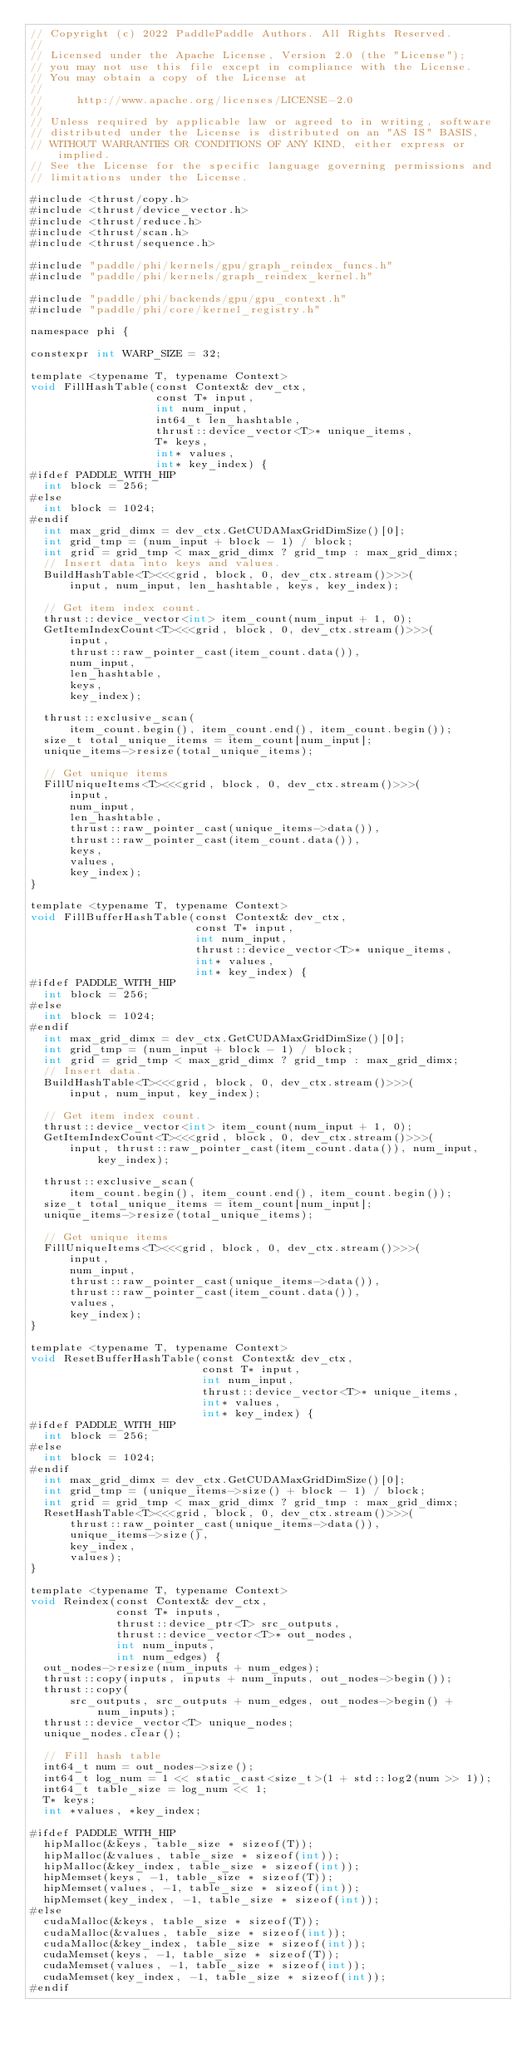Convert code to text. <code><loc_0><loc_0><loc_500><loc_500><_Cuda_>// Copyright (c) 2022 PaddlePaddle Authors. All Rights Reserved.
//
// Licensed under the Apache License, Version 2.0 (the "License");
// you may not use this file except in compliance with the License.
// You may obtain a copy of the License at
//
//     http://www.apache.org/licenses/LICENSE-2.0
//
// Unless required by applicable law or agreed to in writing, software
// distributed under the License is distributed on an "AS IS" BASIS,
// WITHOUT WARRANTIES OR CONDITIONS OF ANY KIND, either express or implied.
// See the License for the specific language governing permissions and
// limitations under the License.

#include <thrust/copy.h>
#include <thrust/device_vector.h>
#include <thrust/reduce.h>
#include <thrust/scan.h>
#include <thrust/sequence.h>

#include "paddle/phi/kernels/gpu/graph_reindex_funcs.h"
#include "paddle/phi/kernels/graph_reindex_kernel.h"

#include "paddle/phi/backends/gpu/gpu_context.h"
#include "paddle/phi/core/kernel_registry.h"

namespace phi {

constexpr int WARP_SIZE = 32;

template <typename T, typename Context>
void FillHashTable(const Context& dev_ctx,
                   const T* input,
                   int num_input,
                   int64_t len_hashtable,
                   thrust::device_vector<T>* unique_items,
                   T* keys,
                   int* values,
                   int* key_index) {
#ifdef PADDLE_WITH_HIP
  int block = 256;
#else
  int block = 1024;
#endif
  int max_grid_dimx = dev_ctx.GetCUDAMaxGridDimSize()[0];
  int grid_tmp = (num_input + block - 1) / block;
  int grid = grid_tmp < max_grid_dimx ? grid_tmp : max_grid_dimx;
  // Insert data into keys and values.
  BuildHashTable<T><<<grid, block, 0, dev_ctx.stream()>>>(
      input, num_input, len_hashtable, keys, key_index);

  // Get item index count.
  thrust::device_vector<int> item_count(num_input + 1, 0);
  GetItemIndexCount<T><<<grid, block, 0, dev_ctx.stream()>>>(
      input,
      thrust::raw_pointer_cast(item_count.data()),
      num_input,
      len_hashtable,
      keys,
      key_index);

  thrust::exclusive_scan(
      item_count.begin(), item_count.end(), item_count.begin());
  size_t total_unique_items = item_count[num_input];
  unique_items->resize(total_unique_items);

  // Get unique items
  FillUniqueItems<T><<<grid, block, 0, dev_ctx.stream()>>>(
      input,
      num_input,
      len_hashtable,
      thrust::raw_pointer_cast(unique_items->data()),
      thrust::raw_pointer_cast(item_count.data()),
      keys,
      values,
      key_index);
}

template <typename T, typename Context>
void FillBufferHashTable(const Context& dev_ctx,
                         const T* input,
                         int num_input,
                         thrust::device_vector<T>* unique_items,
                         int* values,
                         int* key_index) {
#ifdef PADDLE_WITH_HIP
  int block = 256;
#else
  int block = 1024;
#endif
  int max_grid_dimx = dev_ctx.GetCUDAMaxGridDimSize()[0];
  int grid_tmp = (num_input + block - 1) / block;
  int grid = grid_tmp < max_grid_dimx ? grid_tmp : max_grid_dimx;
  // Insert data.
  BuildHashTable<T><<<grid, block, 0, dev_ctx.stream()>>>(
      input, num_input, key_index);

  // Get item index count.
  thrust::device_vector<int> item_count(num_input + 1, 0);
  GetItemIndexCount<T><<<grid, block, 0, dev_ctx.stream()>>>(
      input, thrust::raw_pointer_cast(item_count.data()), num_input, key_index);

  thrust::exclusive_scan(
      item_count.begin(), item_count.end(), item_count.begin());
  size_t total_unique_items = item_count[num_input];
  unique_items->resize(total_unique_items);

  // Get unique items
  FillUniqueItems<T><<<grid, block, 0, dev_ctx.stream()>>>(
      input,
      num_input,
      thrust::raw_pointer_cast(unique_items->data()),
      thrust::raw_pointer_cast(item_count.data()),
      values,
      key_index);
}

template <typename T, typename Context>
void ResetBufferHashTable(const Context& dev_ctx,
                          const T* input,
                          int num_input,
                          thrust::device_vector<T>* unique_items,
                          int* values,
                          int* key_index) {
#ifdef PADDLE_WITH_HIP
  int block = 256;
#else
  int block = 1024;
#endif
  int max_grid_dimx = dev_ctx.GetCUDAMaxGridDimSize()[0];
  int grid_tmp = (unique_items->size() + block - 1) / block;
  int grid = grid_tmp < max_grid_dimx ? grid_tmp : max_grid_dimx;
  ResetHashTable<T><<<grid, block, 0, dev_ctx.stream()>>>(
      thrust::raw_pointer_cast(unique_items->data()),
      unique_items->size(),
      key_index,
      values);
}

template <typename T, typename Context>
void Reindex(const Context& dev_ctx,
             const T* inputs,
             thrust::device_ptr<T> src_outputs,
             thrust::device_vector<T>* out_nodes,
             int num_inputs,
             int num_edges) {
  out_nodes->resize(num_inputs + num_edges);
  thrust::copy(inputs, inputs + num_inputs, out_nodes->begin());
  thrust::copy(
      src_outputs, src_outputs + num_edges, out_nodes->begin() + num_inputs);
  thrust::device_vector<T> unique_nodes;
  unique_nodes.clear();

  // Fill hash table
  int64_t num = out_nodes->size();
  int64_t log_num = 1 << static_cast<size_t>(1 + std::log2(num >> 1));
  int64_t table_size = log_num << 1;
  T* keys;
  int *values, *key_index;

#ifdef PADDLE_WITH_HIP
  hipMalloc(&keys, table_size * sizeof(T));
  hipMalloc(&values, table_size * sizeof(int));
  hipMalloc(&key_index, table_size * sizeof(int));
  hipMemset(keys, -1, table_size * sizeof(T));
  hipMemset(values, -1, table_size * sizeof(int));
  hipMemset(key_index, -1, table_size * sizeof(int));
#else
  cudaMalloc(&keys, table_size * sizeof(T));
  cudaMalloc(&values, table_size * sizeof(int));
  cudaMalloc(&key_index, table_size * sizeof(int));
  cudaMemset(keys, -1, table_size * sizeof(T));
  cudaMemset(values, -1, table_size * sizeof(int));
  cudaMemset(key_index, -1, table_size * sizeof(int));
#endif
</code> 